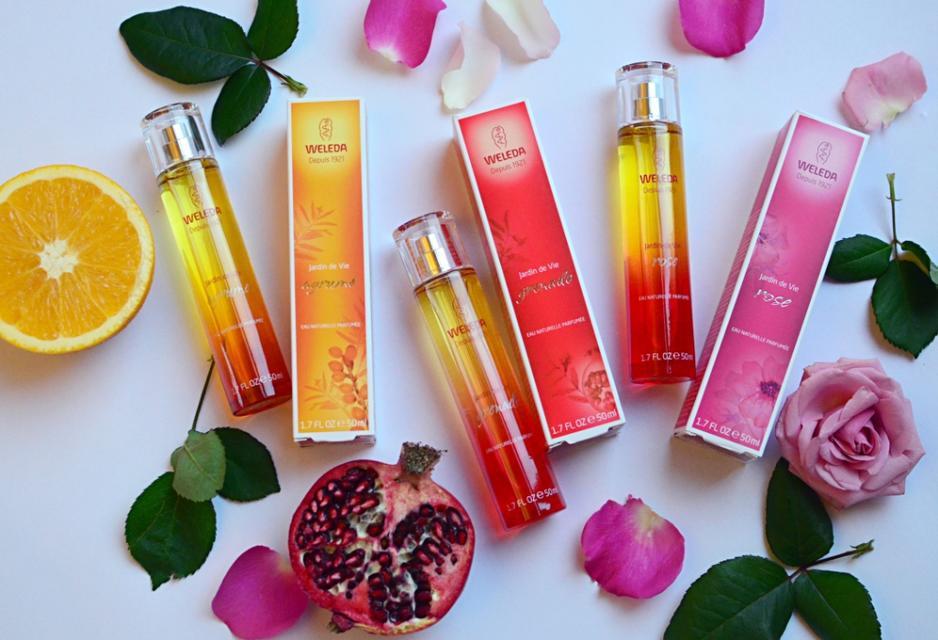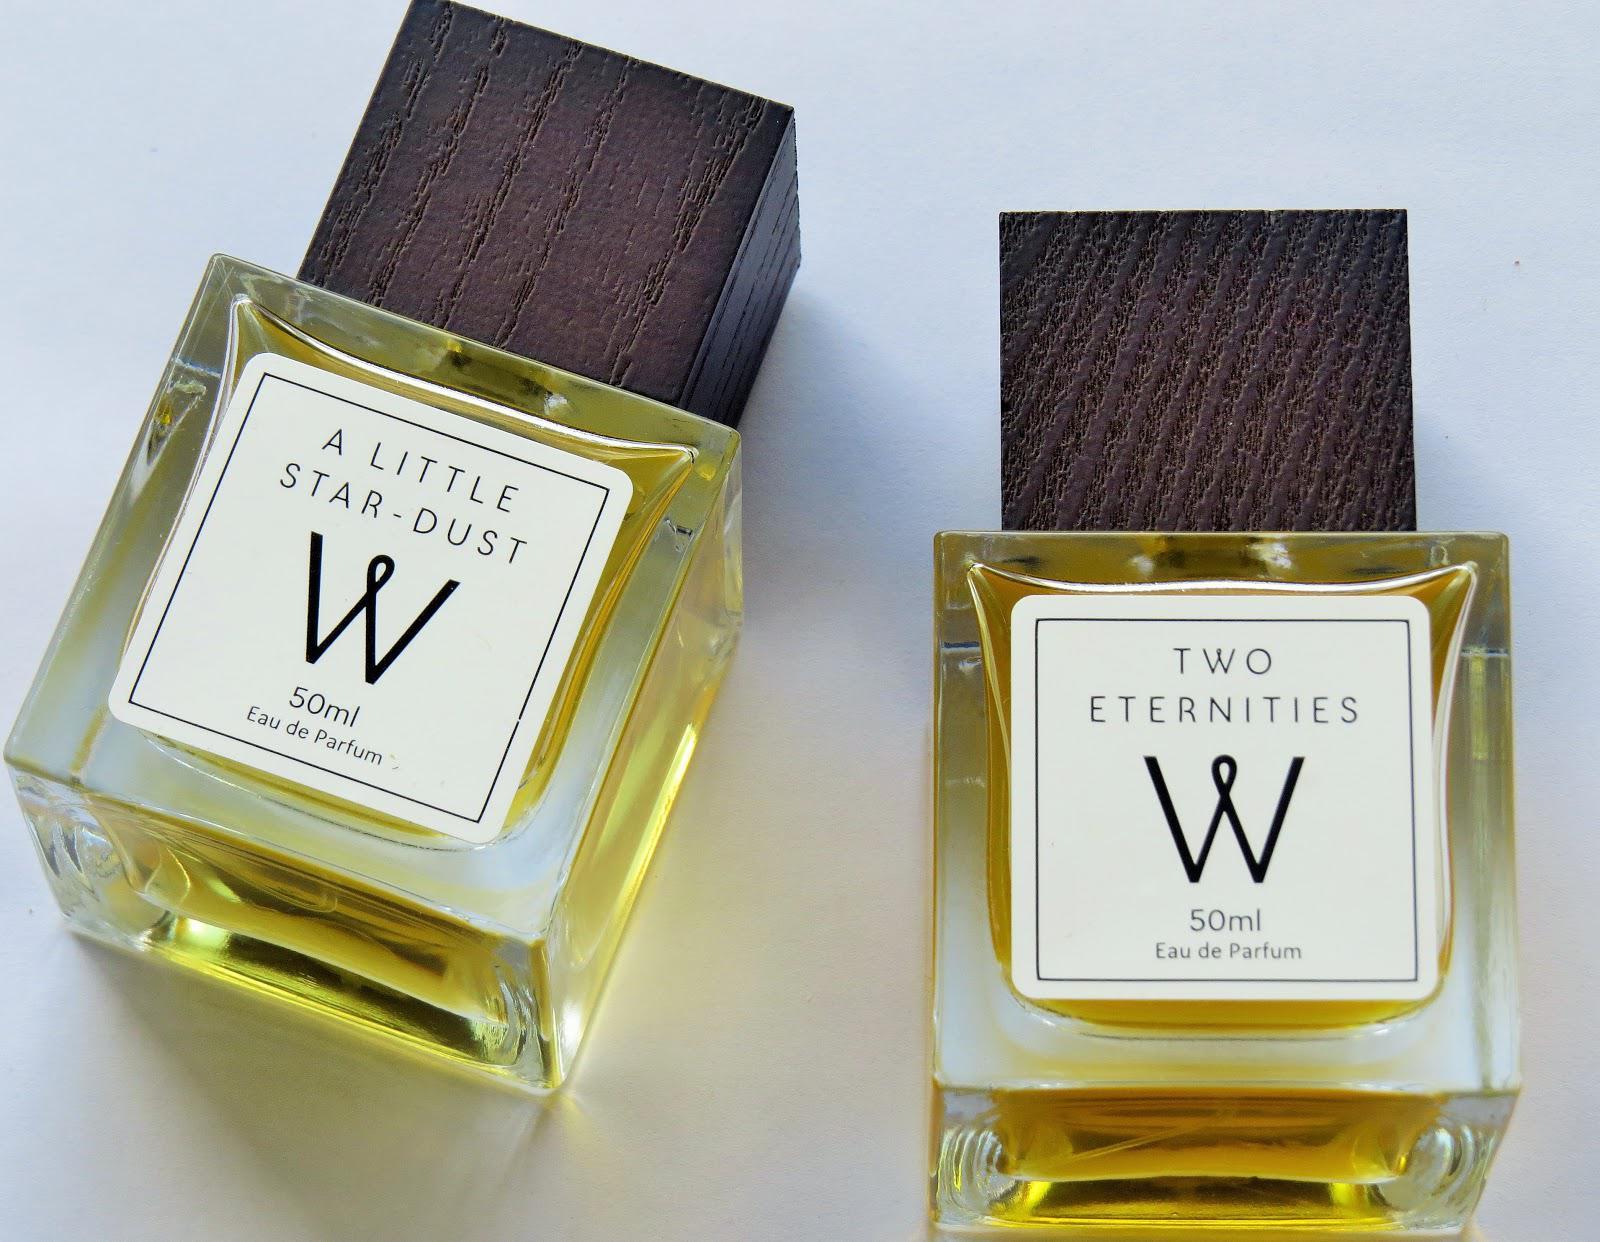The first image is the image on the left, the second image is the image on the right. Examine the images to the left and right. Is the description "The right image contains no more than one perfume container." accurate? Answer yes or no. No. 